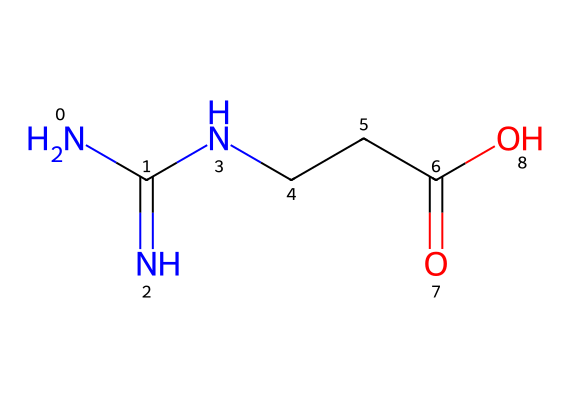What is the name of this chemical? The SMILES representation of the chemical indicates that it consists of nitrogen, carbon, and oxygen atoms arranged in a specific way characteristic of creatine. Therefore, the chemical corresponds to the structure of creatine, commonly used as a supplement in sports.
Answer: creatine How many nitrogen atoms are in the structure? By analyzing the SMILES representation, we observe that there are two nitrogen atoms present in the amino and guanidine groups. Each nitrogen is indicated by 'N' in the structure.
Answer: 2 What type of functional group is represented by the ‘C(=O)O’ part? The ‘C(=O)O’ part of the SMILES denotes a carboxylic acid functional group, where the carbon is double-bonded to an oxygen and single-bonded to an -OH group (hydroxyl). This is typical for amino acids and related compounds.
Answer: carboxylic acid What is the main purpose of creatine supplementation in athletes? Creatine is predominantly used by athletes to enhance performance, particularly in high-intensity exercises, by replenishing energy stores in muscles. This is due to its role in the synthesis of ATP, the energy currency of cells.
Answer: energy boost How many carbon atoms are present in this chemical structure? From the SMILES, we can identify a total of 4 carbon atoms, as each ‘C’ corresponds to a carbon atom. They are arranged in a way that includes a chain with functional groups attached.
Answer: 4 Does this chemical structure contain any acidic properties? Yes, the presence of the carboxylic acid functional group indicates that the structure has acidic properties, as carboxylic acids can donate protons (H+) in solution.
Answer: yes Which part of this structure is indicative of its role in protein synthesis? The presence of the amino group (NH2) attached to one of the carbon atoms is indicative of its role in protein synthesis, as amino groups are fundamental in the formation of amino acids, the building blocks of proteins.
Answer: amino group 